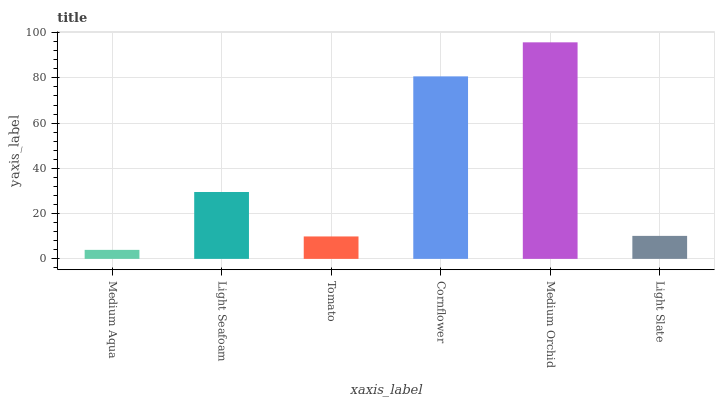Is Medium Aqua the minimum?
Answer yes or no. Yes. Is Medium Orchid the maximum?
Answer yes or no. Yes. Is Light Seafoam the minimum?
Answer yes or no. No. Is Light Seafoam the maximum?
Answer yes or no. No. Is Light Seafoam greater than Medium Aqua?
Answer yes or no. Yes. Is Medium Aqua less than Light Seafoam?
Answer yes or no. Yes. Is Medium Aqua greater than Light Seafoam?
Answer yes or no. No. Is Light Seafoam less than Medium Aqua?
Answer yes or no. No. Is Light Seafoam the high median?
Answer yes or no. Yes. Is Light Slate the low median?
Answer yes or no. Yes. Is Medium Aqua the high median?
Answer yes or no. No. Is Medium Aqua the low median?
Answer yes or no. No. 